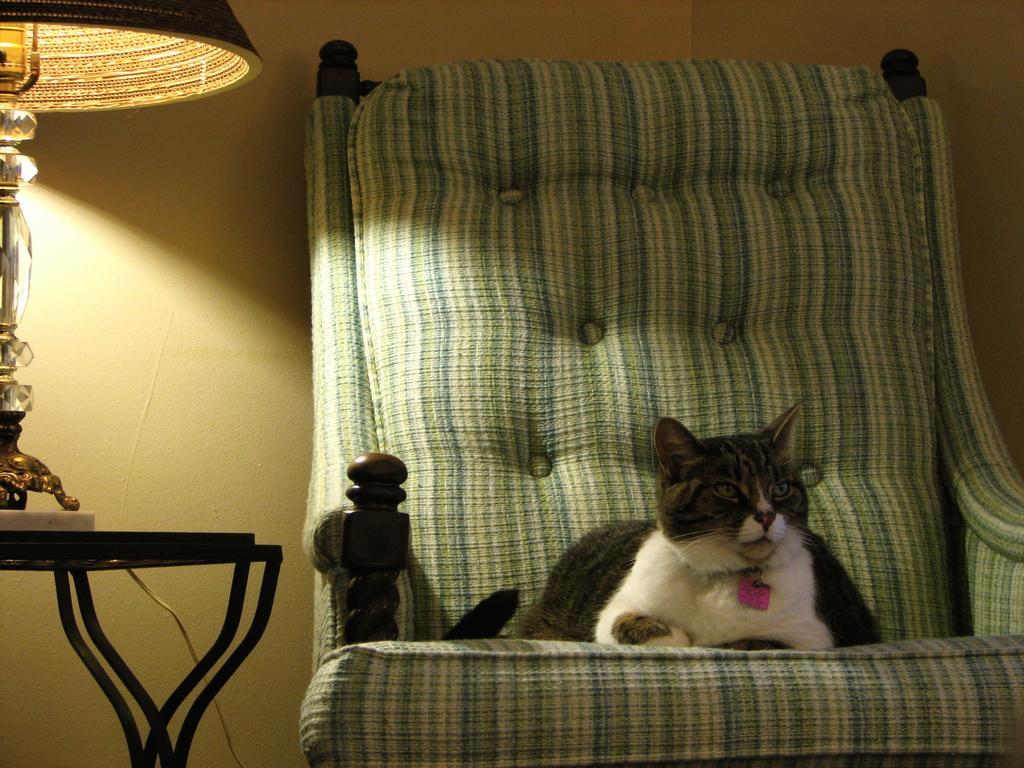How would you summarize this image in a sentence or two? In this image, we can see cat is sat on the chair. On left side, there is a table and lamp on the table. And background, there is a cream color wall. 